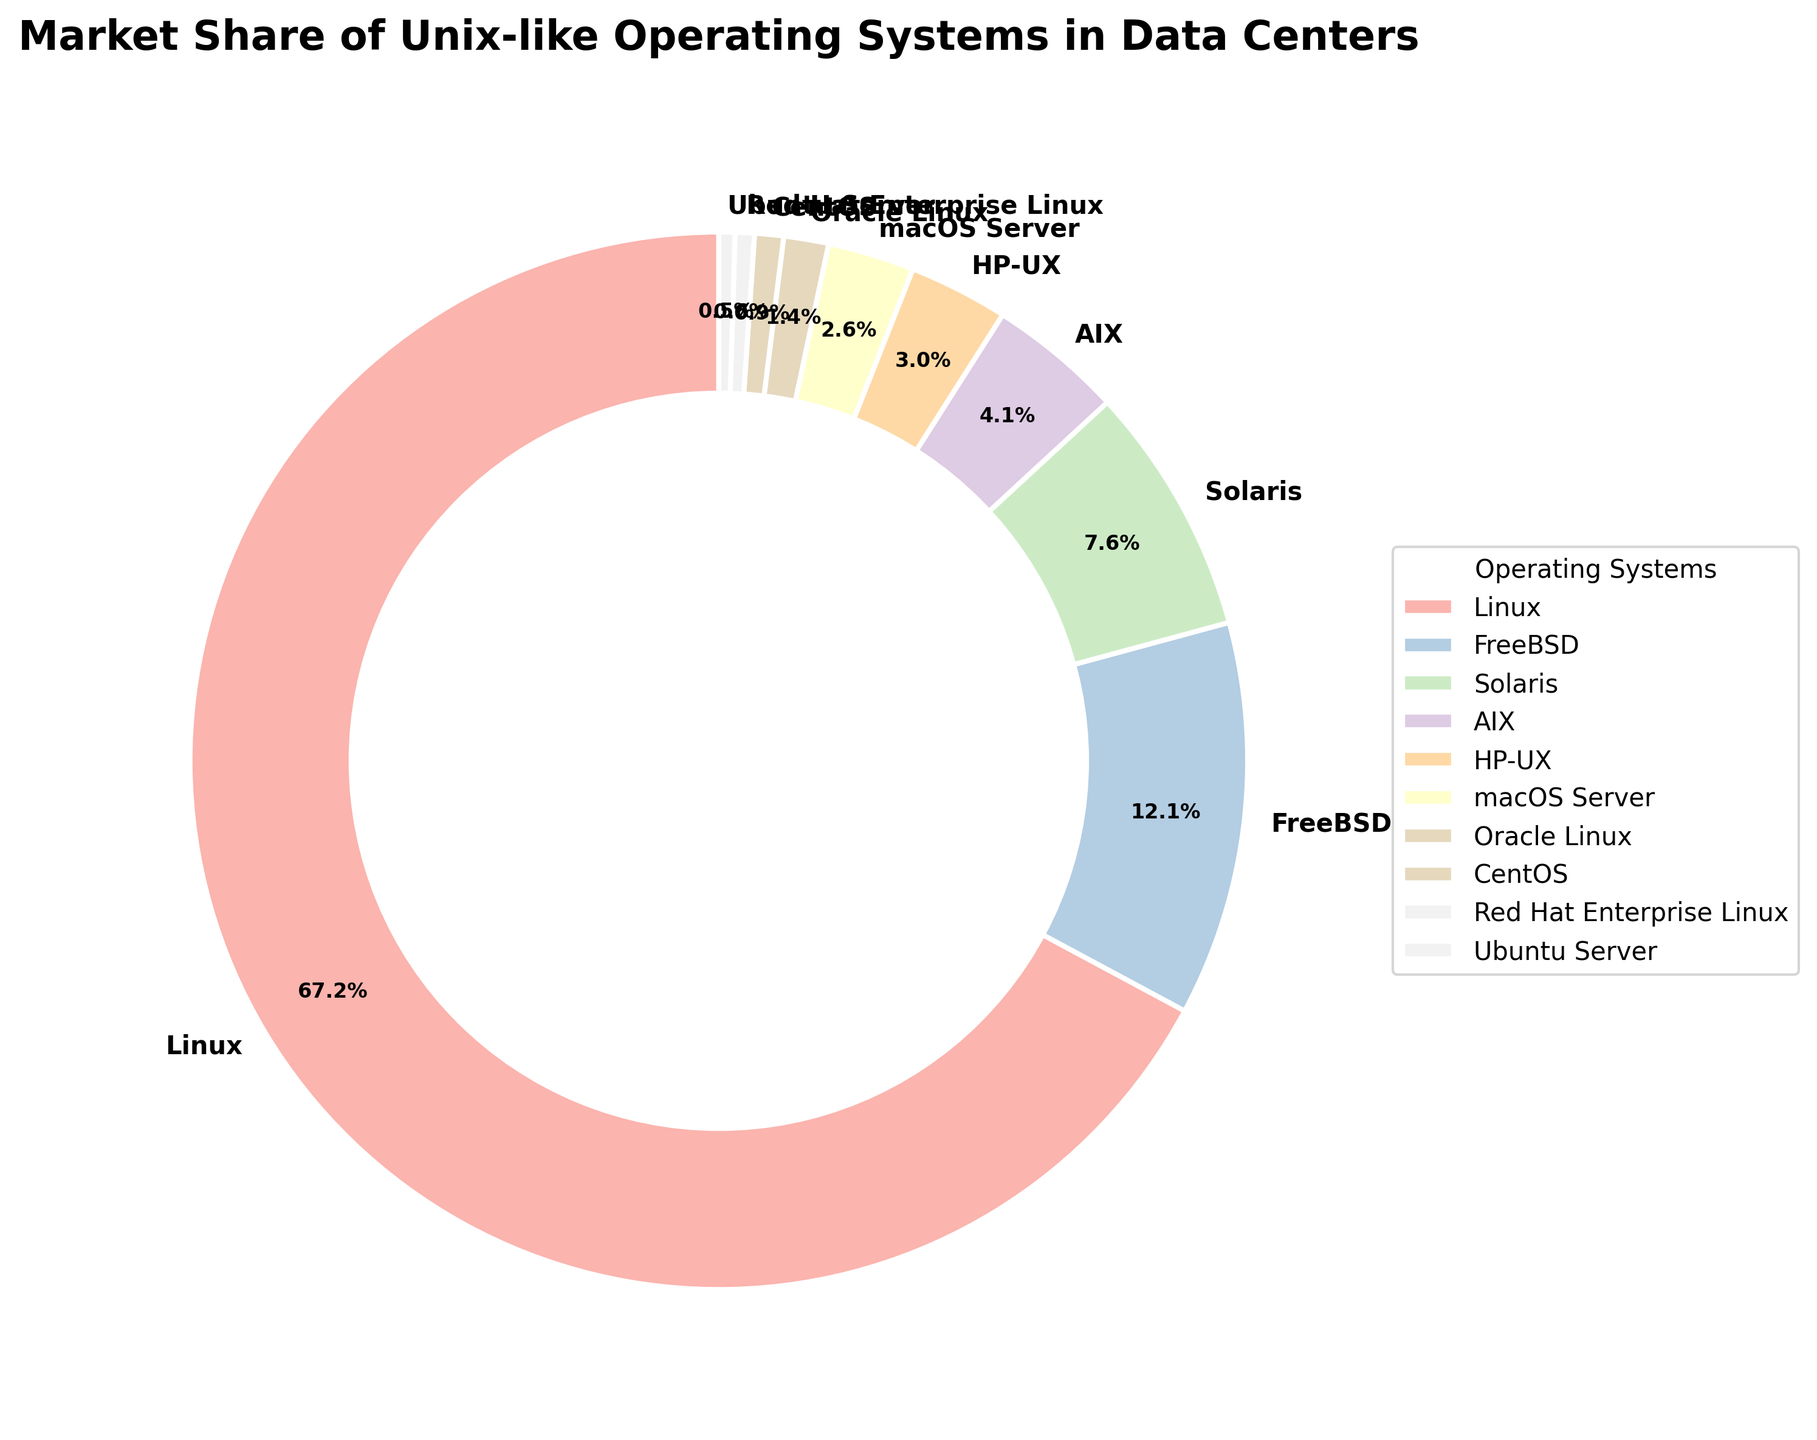What is the market share of Linux? From the figure, identify the market share percentage indicated next to the label "Linux".
Answer: 68.5% Which operating system has the largest market share? Identify the segment with the largest size and corresponding label. Linux is the largest segment with a 68.5% market share.
Answer: Linux What is the combined market share of FreeBSD and Solaris? Look at the percentages for FreeBSD (12.3%) and Solaris (7.8%) and add them together: 12.3 + 7.8.
Answer: 20.1% Which operating system has a smaller market share, CentOS or Red Hat Enterprise Linux? Compare the percentages for CentOS (0.9%) and Red Hat Enterprise Linux (0.6%). Red Hat Enterprise Linux has a smaller market share.
Answer: Red Hat Enterprise Linux Order the operating systems by their market share from highest to lowest. List and arrange the operating systems by their market share percentages: Linux (68.5%), FreeBSD (12.3%), Solaris (7.8%), AIX (4.2%), HP-UX (3.1%), macOS Server (2.7%), Oracle Linux (1.4%), CentOS (0.9%), Red Hat Enterprise Linux (0.6%), Ubuntu Server (0.5%).
Answer: Linux, FreeBSD, Solaris, AIX, HP-UX, macOS Server, Oracle Linux, CentOS, Red Hat Enterprise Linux, Ubuntu Server What is the difference in market share between macOS Server and AIX? Subtract the market share percentage of AIX (4.2%) from macOS Server (2.7%): 4.2 - 2.7.
Answer: 1.5 Which operating system has a market share represented by the lightest pastel color? Visually identify the lightest segment, which corresponds to Ubuntu Server, having a market share of 0.5%
Answer: Ubuntu Server What percentage of the market do Oracle Linux and CentOS share together? Add the market share percentages of Oracle Linux (1.4%) and CentOS (0.9%): 1.4 + 0.9.
Answer: 2.3% Identify the market share of the operating system represented by the darkest pastel color. Visually identify the darkest segment and find the corresponding label and percentage. The darkest segment is Linux with 68.5%.
Answer: 68.5% What is the total market share of operating systems that have less than 5% market share each? Sum up market shares of the segments with less than 5%: HP-UX (3.1%), macOS Server (2.7%), Oracle Linux (1.4%), CentOS (0.9%), Red Hat Enterprise Linux (0.6%), Ubuntu Server (0.5%). Total: 3.1 + 2.7 + 1.4 + 0.9 + 0.6 + 0.5 = 9.2%.
Answer: 9.2% 